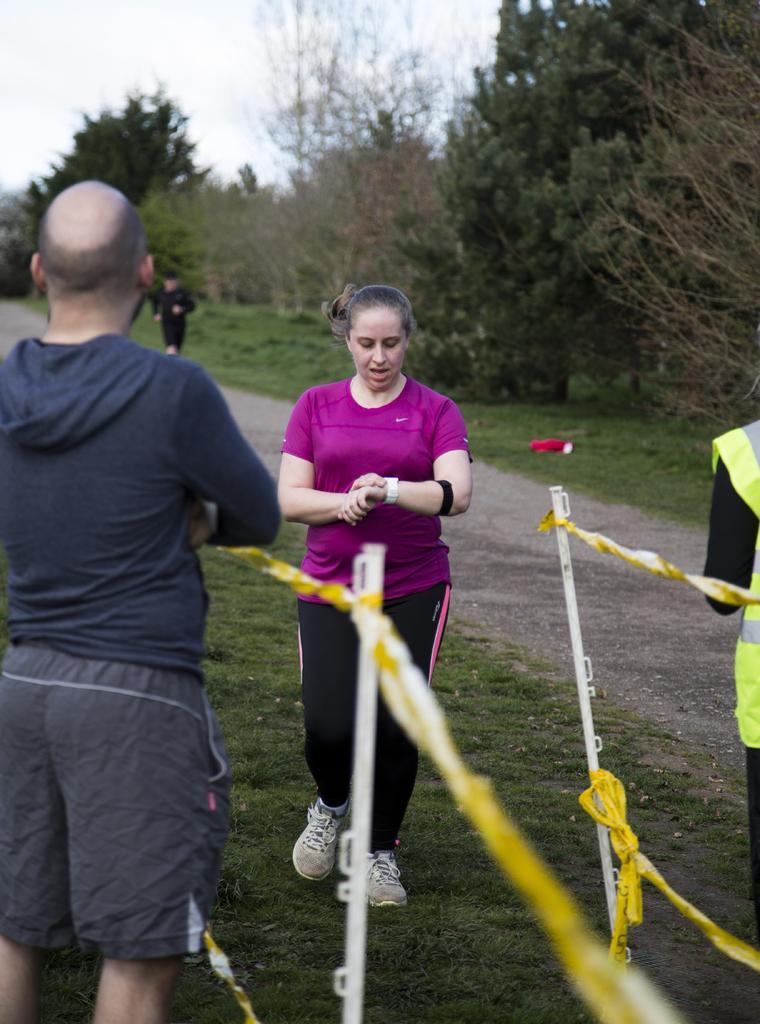Describe this image in one or two sentences. In this image we can see few persons are standing on the grass, ropes and poles. In the background we can see a person, path, trees and the sky. 